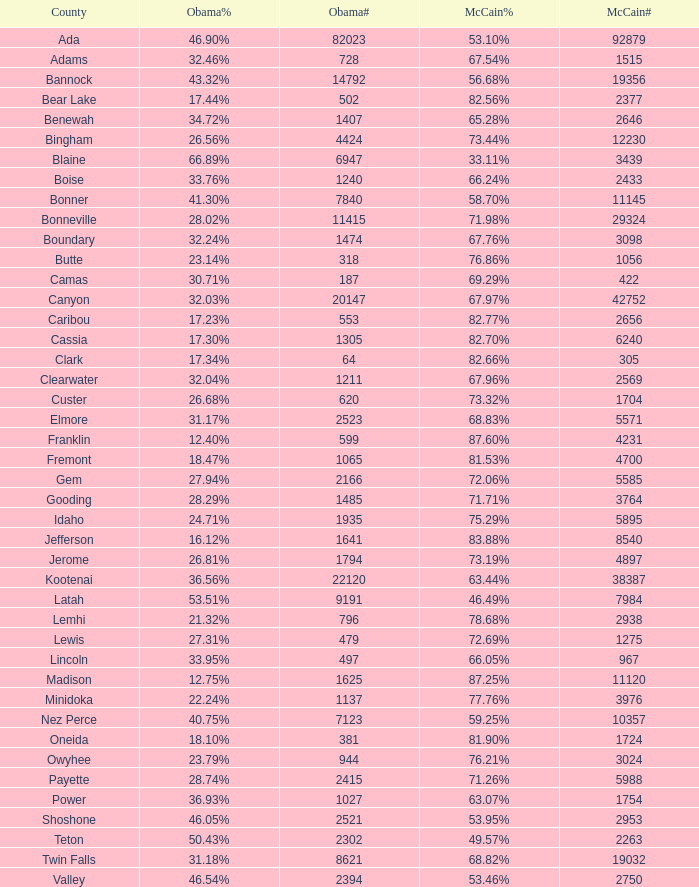What is the maximum mccain population participation number? 92879.0. 